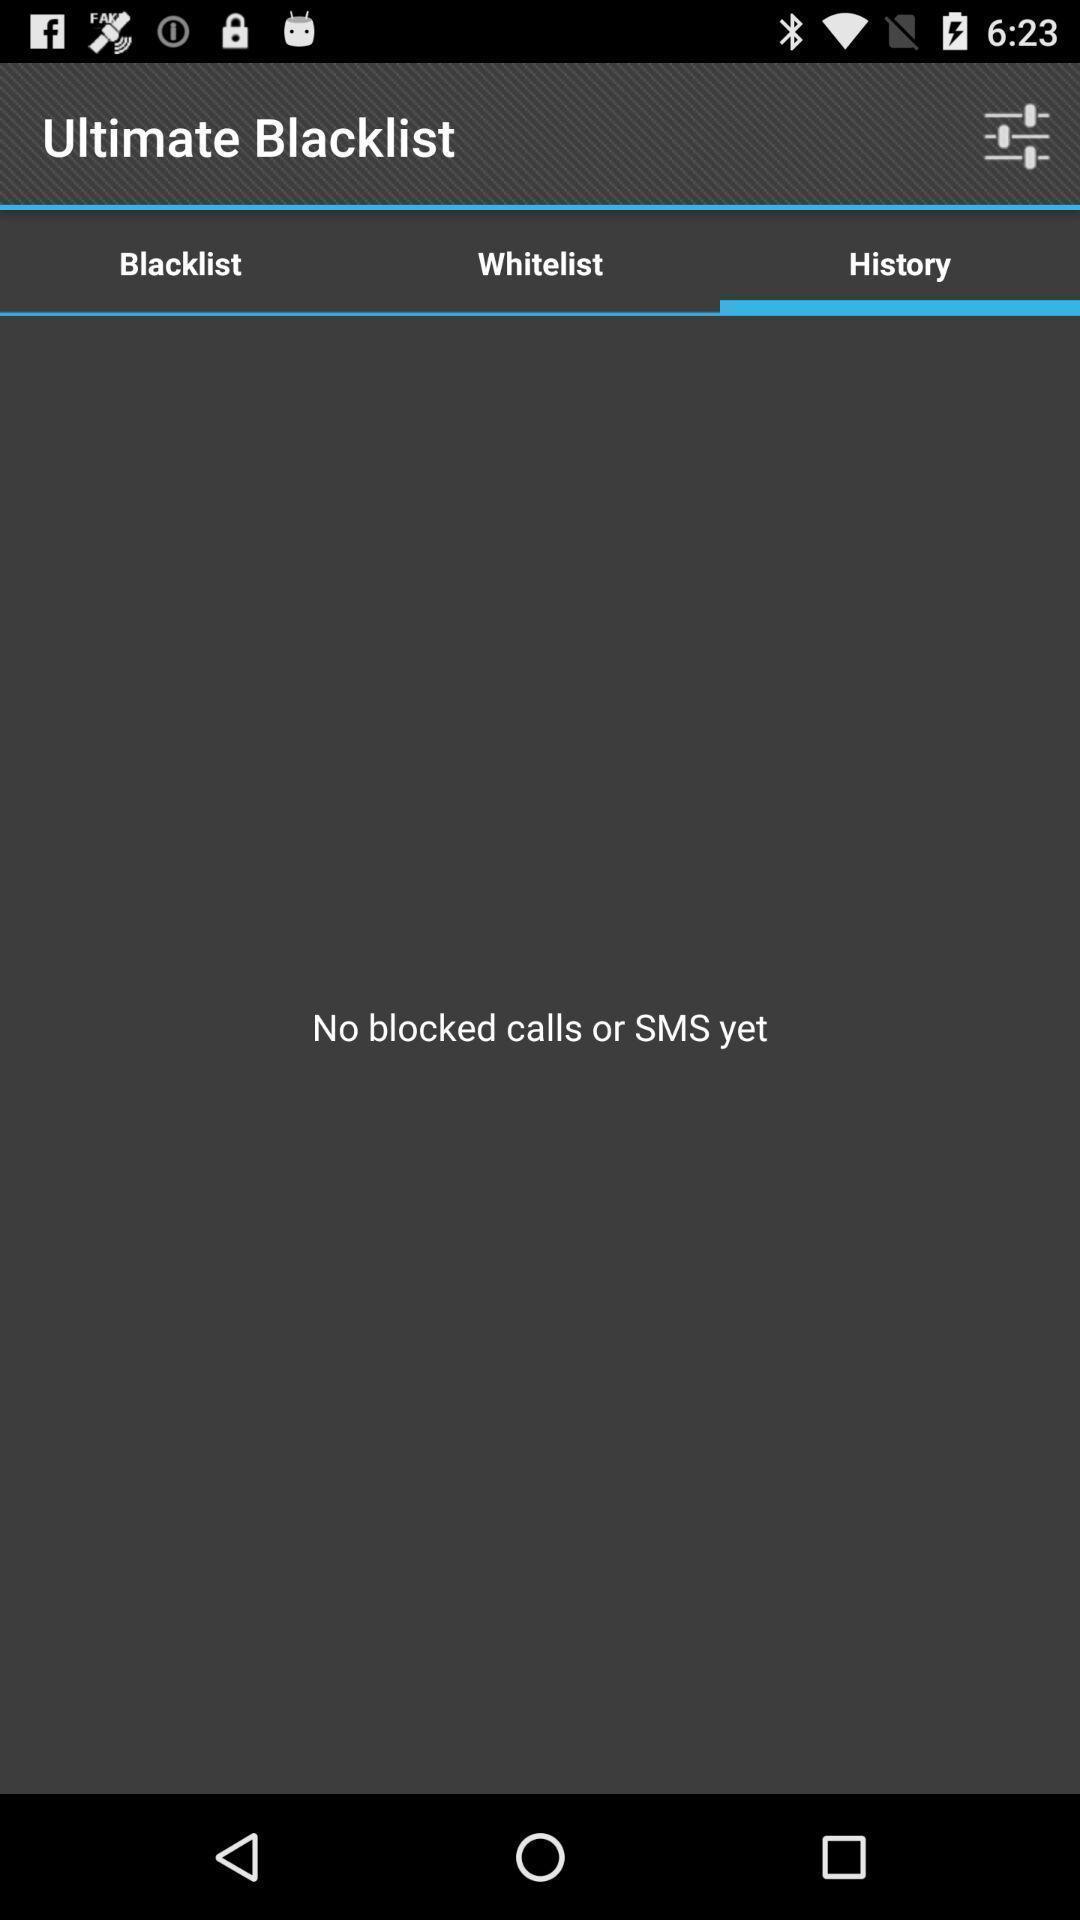Describe the visual elements of this screenshot. Page displaying options and buttons in an call application. 